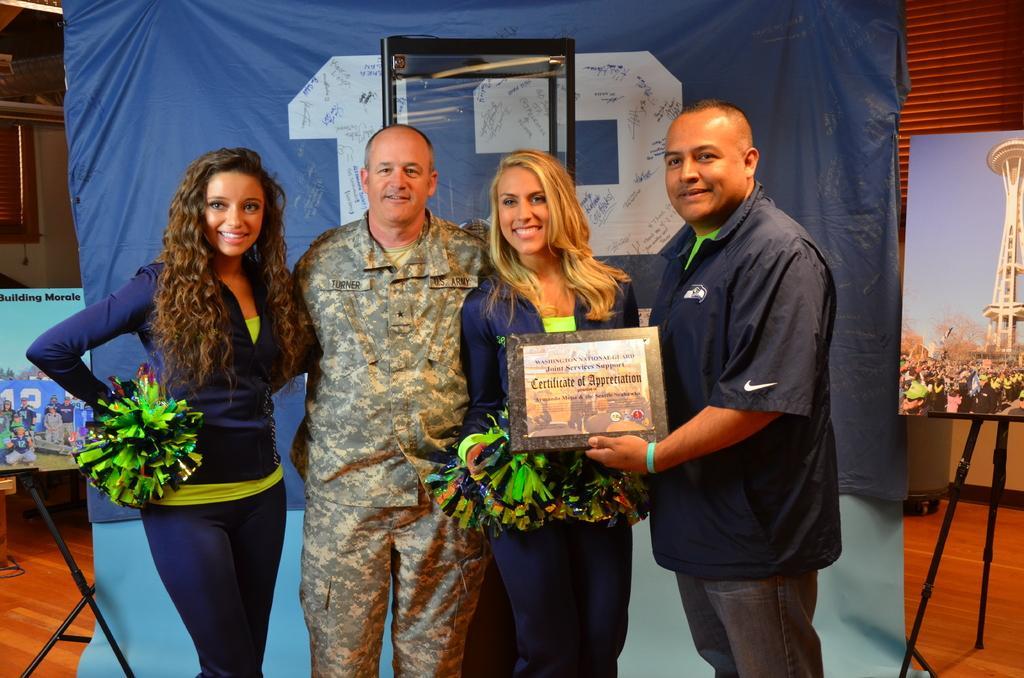Please provide a concise description of this image. In this image we can see few people standing and posing for a photo in a room and there are two persons holding an object with some text. There is a banner in the background, we can see some text on it and there are two photo frames with pictures and we can see some other objects in the room. 